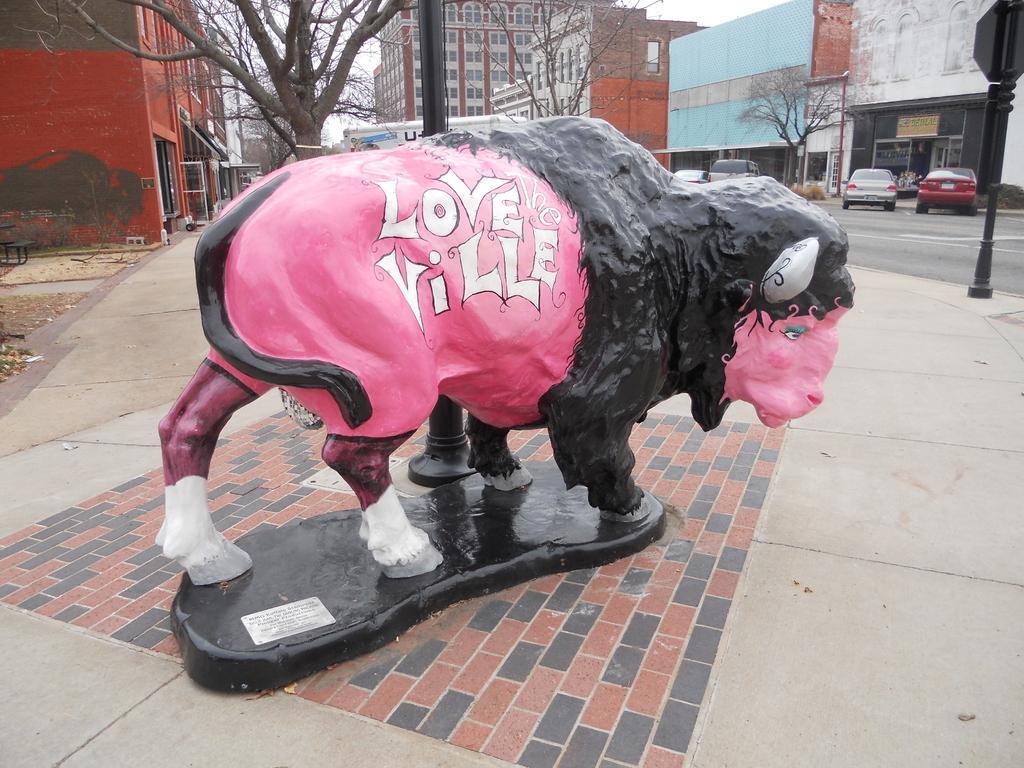Could you give a brief overview of what you see in this image? In this image there is a depiction of a sheep on the pavement, there are few vehicles parked in a side of a road. In the background there buildings and trees. 